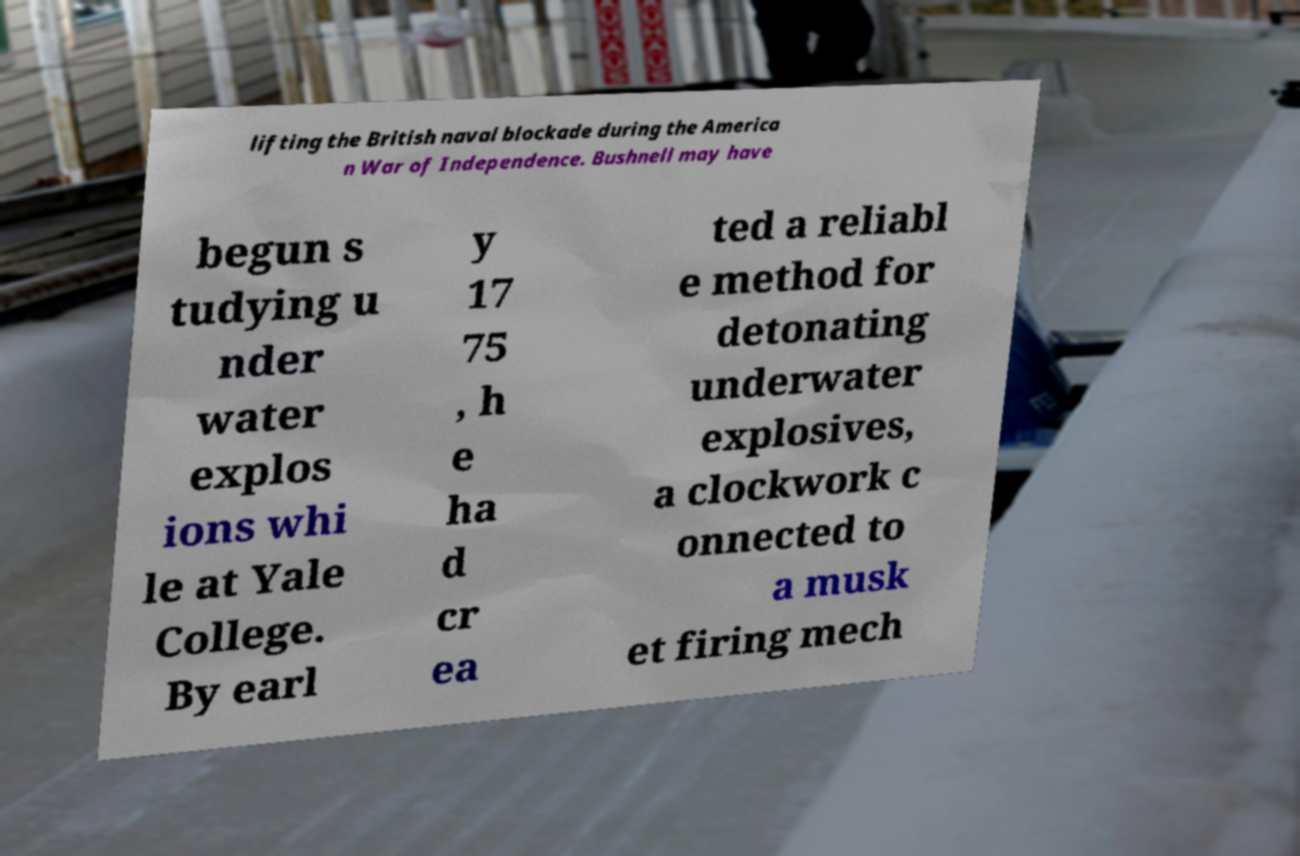Could you assist in decoding the text presented in this image and type it out clearly? lifting the British naval blockade during the America n War of Independence. Bushnell may have begun s tudying u nder water explos ions whi le at Yale College. By earl y 17 75 , h e ha d cr ea ted a reliabl e method for detonating underwater explosives, a clockwork c onnected to a musk et firing mech 